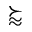Convert formula to latex. <formula><loc_0><loc_0><loc_500><loc_500>\succ a p p r o x</formula> 